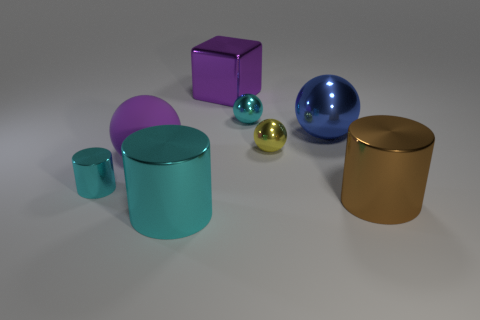Can you describe the texture and finish of the objects in the image? Certainly! The objects in the image have smooth, reflective surfaces, indicating a metallic or polished finish. The reflections and the soft shadows created by the lighting setup contribute to a perception of a texture that is glossy and sleek. 